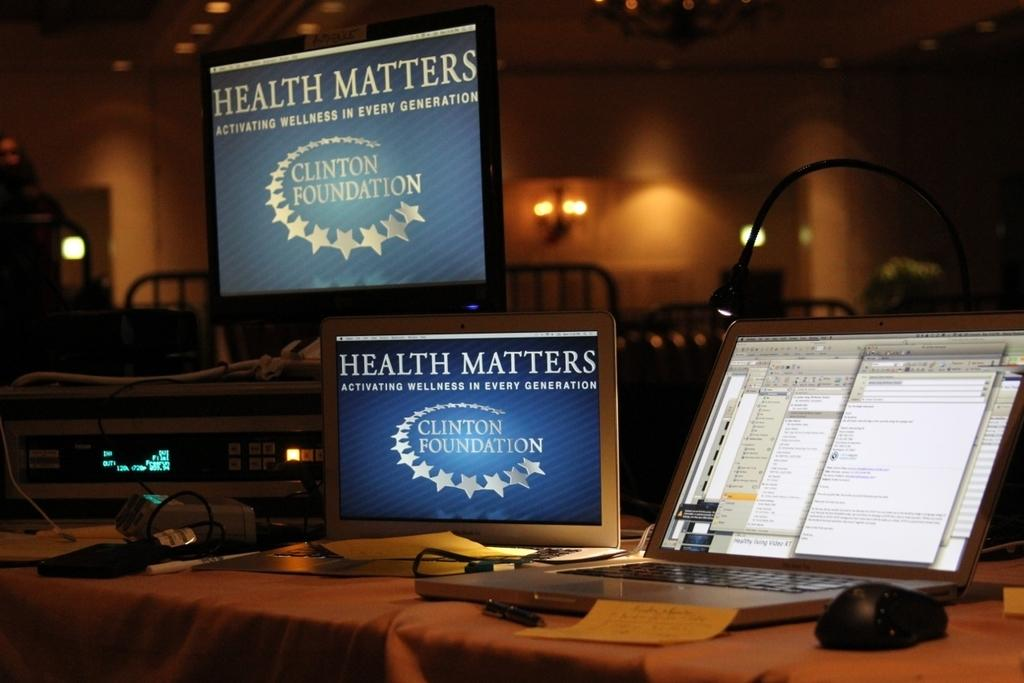<image>
Offer a succinct explanation of the picture presented. the words health matters is on the screens 